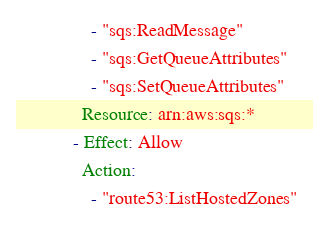<code> <loc_0><loc_0><loc_500><loc_500><_YAML_>                - "sqs:ReadMessage"
                - "sqs:GetQueueAttributes"
                - "sqs:SetQueueAttributes"
              Resource: arn:aws:sqs:*
            - Effect: Allow
              Action:
                - "route53:ListHostedZones"</code> 